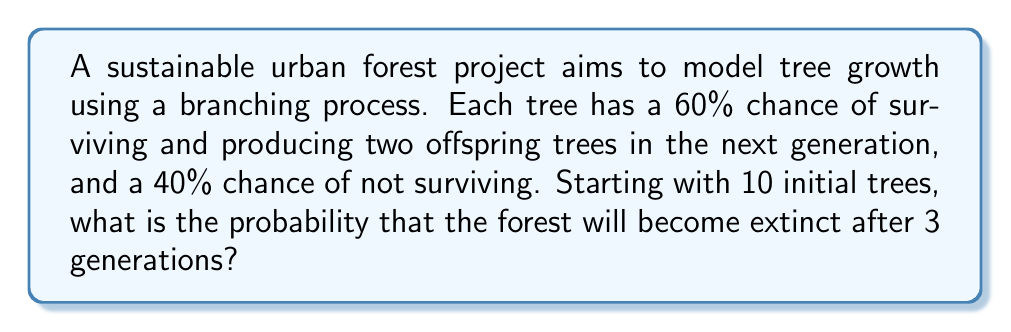Provide a solution to this math problem. Let's approach this step-by-step using the theory of branching processes:

1) First, we need to calculate the probability of extinction for a single tree after one generation. Let's call this probability $q$.

2) The probability generating function for this process is:
   $$f(s) = 0.4 + 0.6s^2$$

3) The extinction probability $q$ is the smallest non-negative root of the equation $s = f(s)$. So we need to solve:
   $$s = 0.4 + 0.6s^2$$

4) This is a quadratic equation. Rearranging:
   $$0.6s^2 - s + 0.4 = 0$$

5) Using the quadratic formula, we get:
   $$s = \frac{1 \pm \sqrt{1 - 4(0.6)(0.4)}}{2(0.6)} = \frac{1 \pm \sqrt{0.04}}{1.2} = \frac{1 \pm 0.2}{1.2}$$

6) The smaller root is:
   $$q = \frac{1 - 0.2}{1.2} = \frac{0.8}{1.2} = \frac{2}{3}$$

7) Now, for the forest to become extinct after 3 generations, all 10 initial trees must have extinct family lines after 3 generations.

8) The probability of extinction for a single family line after 3 generations is:
   $$q_3 = q + (1-q)q^2 + (1-q)^2q = \frac{2}{3} + \frac{1}{3} \cdot \frac{4}{9} + \frac{1}{9} \cdot \frac{2}{3} = \frac{26}{27}$$

9) For all 10 family lines to become extinct, we raise this probability to the 10th power:
   $$P(\text{forest extinction}) = \left(\frac{26}{27}\right)^{10}$$

10) Calculating this gives us the final probability.
Answer: $\left(\frac{26}{27}\right)^{10} \approx 0.6866$ 